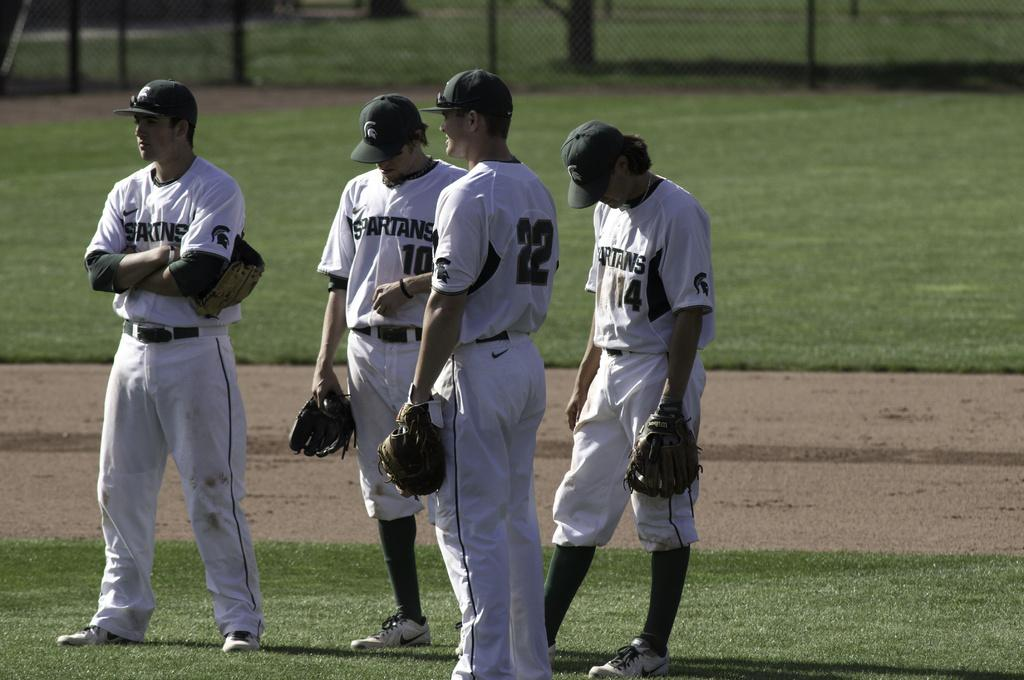<image>
Summarize the visual content of the image. Several players for the Spartans baseball team stand on the field. 